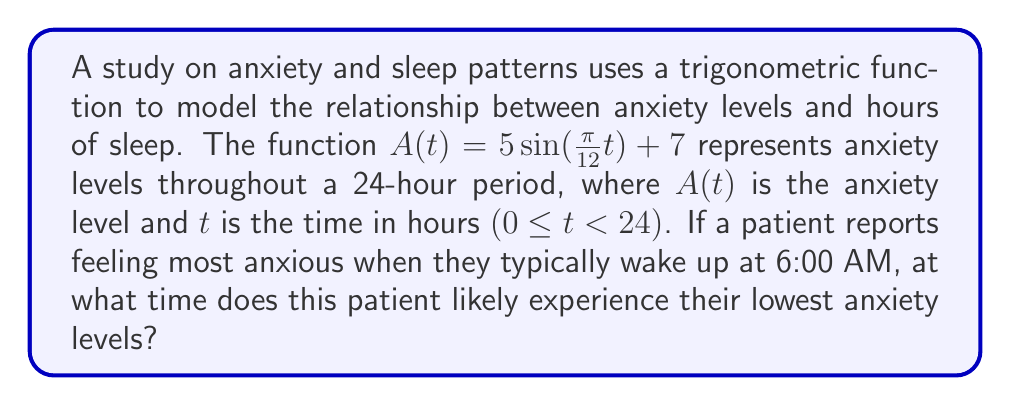Show me your answer to this math problem. 1) First, we need to understand the given function:
   $A(t) = 5\sin(\frac{\pi}{12}t) + 7$

2) The period of this function is 24 hours, as $\frac{2\pi}{\frac{\pi}{12}} = 24$.

3) The patient reports highest anxiety at 6:00 AM, which corresponds to t = 6.

4) For a sine function, the lowest point occurs half a period (12 hours) after the highest point.

5) To find the time of lowest anxiety, we add 12 hours to 6:00 AM:
   6:00 AM + 12 hours = 6:00 PM

6) We can verify this mathematically:
   At t = 6 (6:00 AM): $A(6) = 5\sin(\frac{\pi}{12}*6) + 7 = 5\sin(\frac{\pi}{2}) + 7 = 12$
   At t = 18 (6:00 PM): $A(18) = 5\sin(\frac{\pi}{12}*18) + 7 = 5\sin(\frac{3\pi}{2}) + 7 = 2$

7) Indeed, the anxiety level is lowest at t = 18, which corresponds to 6:00 PM.
Answer: 6:00 PM 